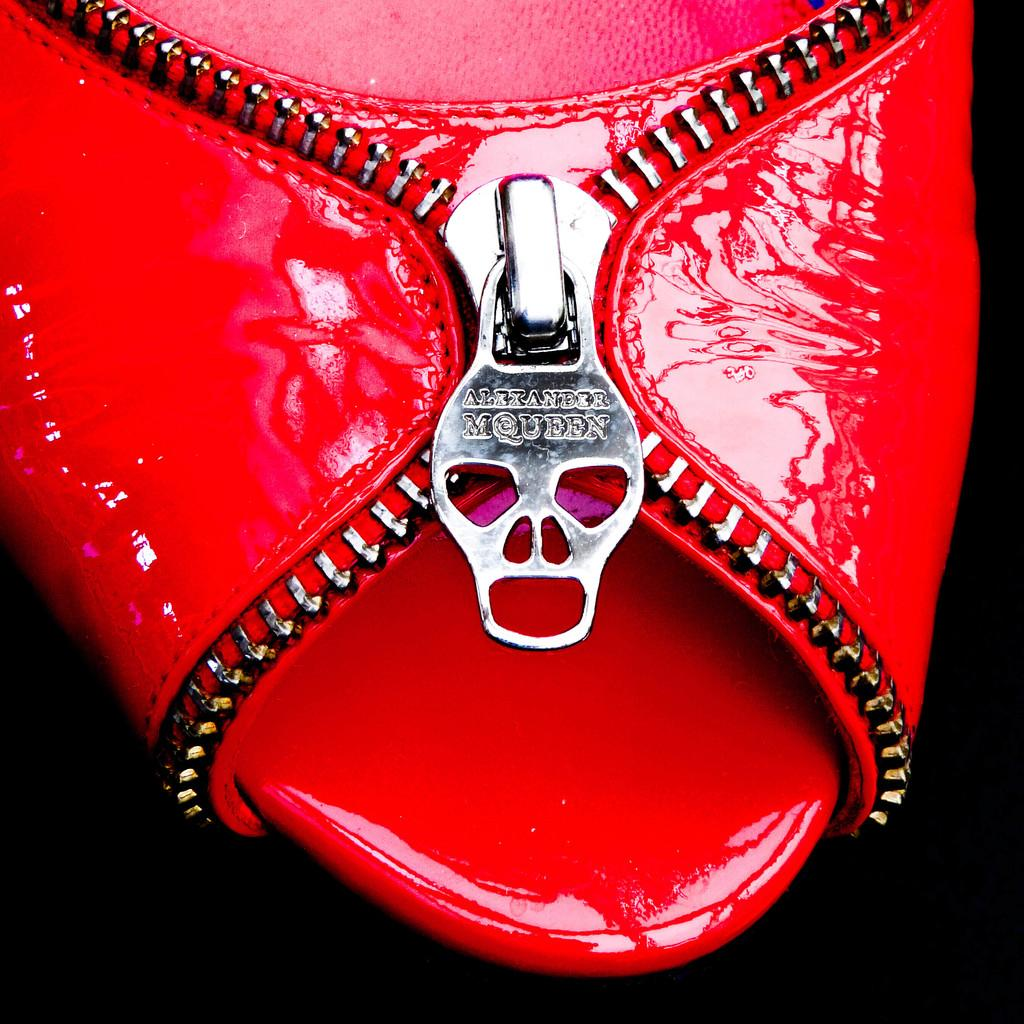What type of object is present in the image? There is a footwear in the image. Can you describe the color of the footwear? The footwear is red in color. Are there any boats visible in the image? No, there are no boats present in the image. What type of winter clothing is shown in the image? There is no winter clothing, such as mittens, present in the image. 